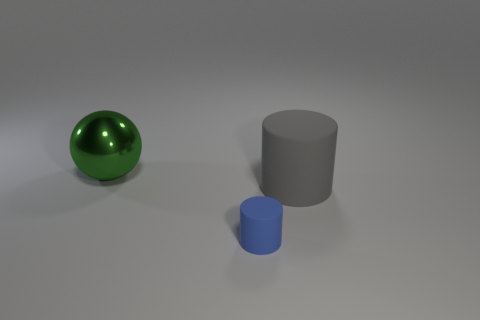Add 1 large blue rubber balls. How many objects exist? 4 Subtract all spheres. How many objects are left? 2 Subtract all large gray rubber things. Subtract all green metallic objects. How many objects are left? 1 Add 3 big metal things. How many big metal things are left? 4 Add 1 small metallic cylinders. How many small metallic cylinders exist? 1 Subtract 0 brown blocks. How many objects are left? 3 